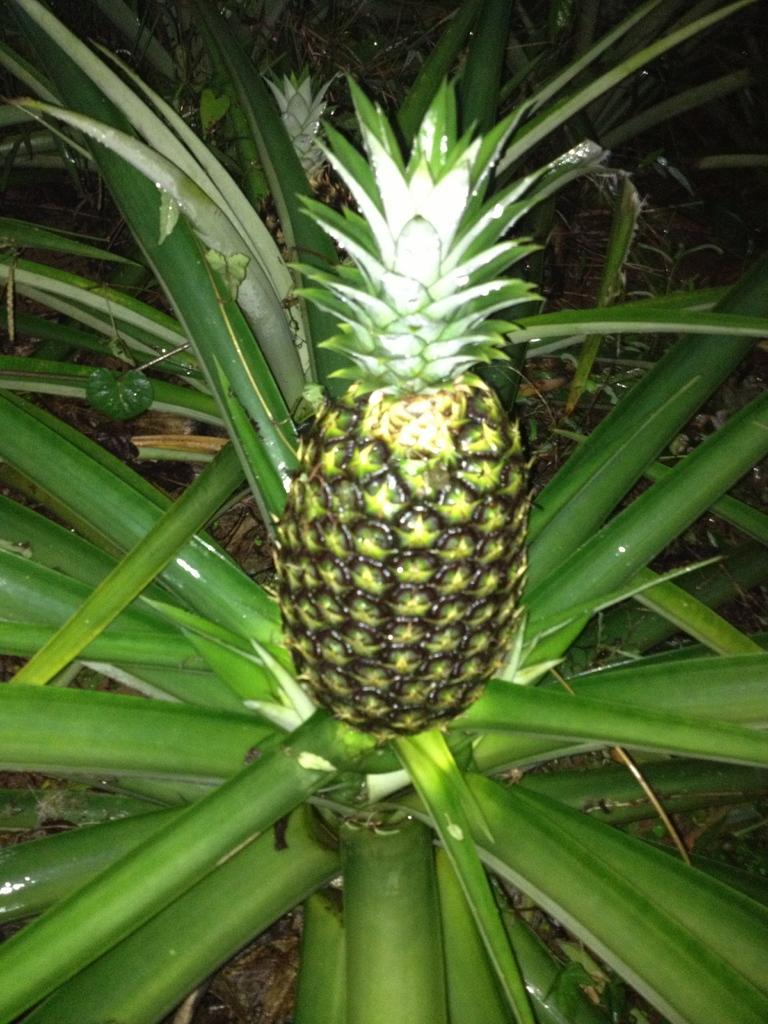Could you give a brief overview of what you see in this image? In this image I can see a pineapple plant. The background of the image is dark. 